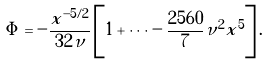Convert formula to latex. <formula><loc_0><loc_0><loc_500><loc_500>\Phi = - \frac { x ^ { - 5 / 2 } } { 3 2 \nu } \left [ 1 + \cdots - \frac { 2 5 6 0 } { 7 } \nu ^ { 2 } x ^ { 5 } \right ] .</formula> 